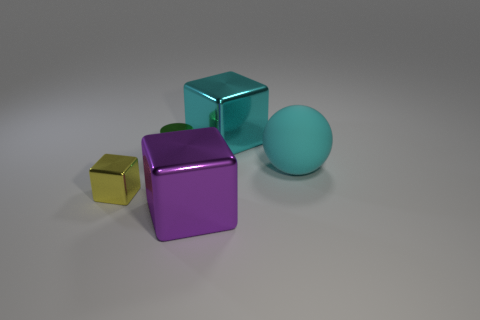Are there any green shiny balls?
Make the answer very short. No. What shape is the big metallic thing behind the purple block?
Provide a short and direct response. Cube. How many objects are both behind the big rubber object and on the right side of the big purple object?
Offer a terse response. 1. How many other things are the same size as the green metal object?
Give a very brief answer. 1. Is the shape of the big thing that is behind the cyan ball the same as the small object in front of the small green cylinder?
Give a very brief answer. Yes. What number of things are cyan metallic cylinders or things right of the small yellow shiny block?
Make the answer very short. 4. What is the object that is to the right of the purple object and behind the rubber ball made of?
Your answer should be very brief. Metal. Is there any other thing that is the same shape as the purple shiny thing?
Give a very brief answer. Yes. There is a tiny cube that is made of the same material as the cylinder; what color is it?
Your answer should be compact. Yellow. How many objects are cyan balls or purple shiny objects?
Your response must be concise. 2. 